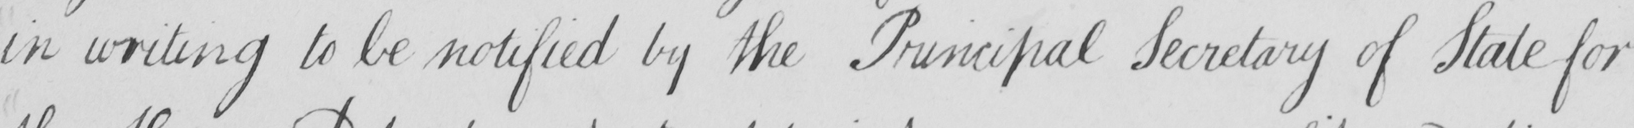Please transcribe the handwritten text in this image. in writing to be notified by the Pruncipal Secretary of State for 